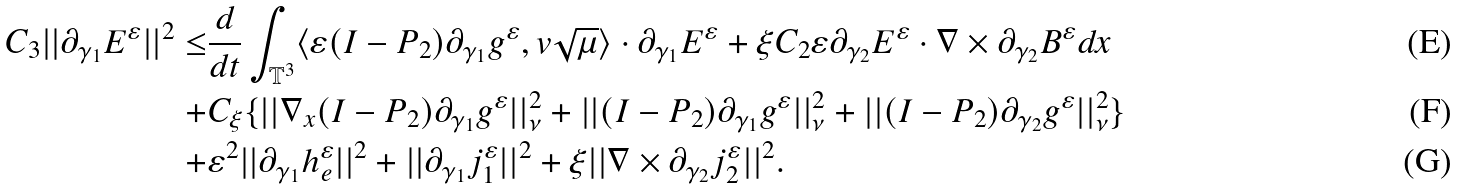<formula> <loc_0><loc_0><loc_500><loc_500>C _ { 3 } | | \partial _ { \gamma _ { 1 } } E ^ { \varepsilon } | | ^ { 2 } \leq & \frac { d } { d t } \int _ { \mathbb { T } ^ { 3 } } \langle \varepsilon ( I - P _ { 2 } ) \partial _ { \gamma _ { 1 } } g ^ { \varepsilon } , v \sqrt { \mu } \rangle \cdot \partial _ { \gamma _ { 1 } } E ^ { \varepsilon } + \xi C _ { 2 } \varepsilon \partial _ { \gamma _ { 2 } } E ^ { \varepsilon } \cdot \nabla \times \partial _ { \gamma _ { 2 } } B ^ { \varepsilon } d x \\ + & C _ { \xi } \{ | | \nabla _ { x } ( I - P _ { 2 } ) \partial _ { \gamma _ { 1 } } g ^ { \varepsilon } | | _ { \nu } ^ { 2 } + | | ( I - P _ { 2 } ) \partial _ { \gamma _ { 1 } } g ^ { \varepsilon } | | _ { \nu } ^ { 2 } + | | ( I - P _ { 2 } ) \partial _ { \gamma _ { 2 } } g ^ { \varepsilon } | | _ { \nu } ^ { 2 } \} \\ + & \varepsilon ^ { 2 } | | \partial _ { \gamma _ { 1 } } h _ { e } ^ { \varepsilon } | | ^ { 2 } + | | \partial _ { \gamma _ { 1 } } j _ { 1 } ^ { \varepsilon } | | ^ { 2 } + \xi | | \nabla \times \partial _ { \gamma _ { 2 } } j _ { 2 } ^ { \varepsilon } | | ^ { 2 } .</formula> 